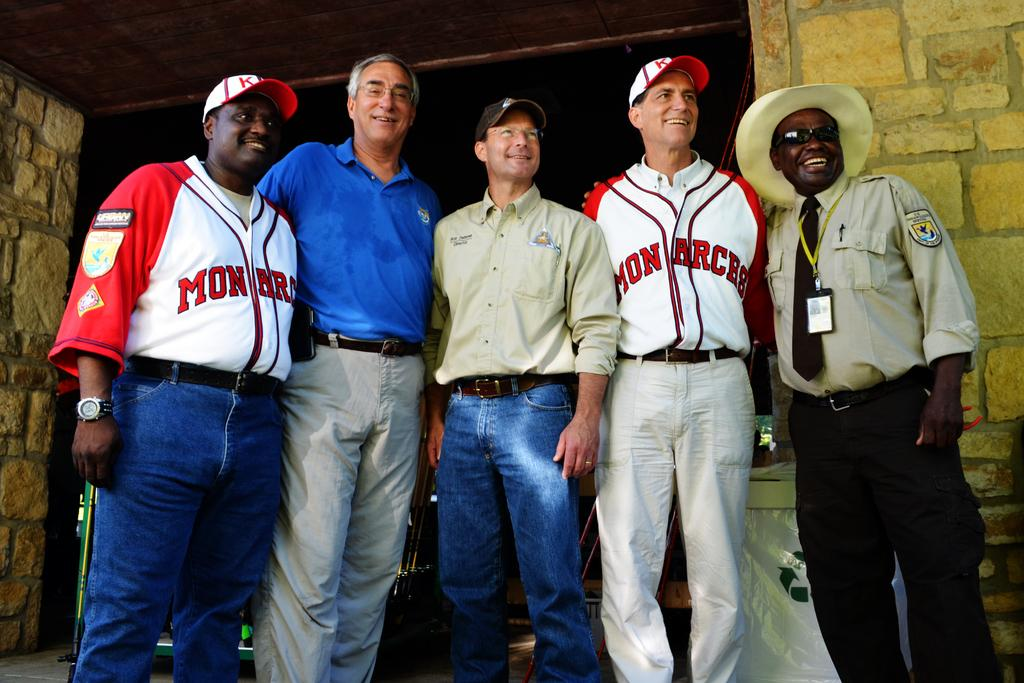Provide a one-sentence caption for the provided image. 5 men are lined up for a picture, 2 of them wearing Monarch jerseys. 